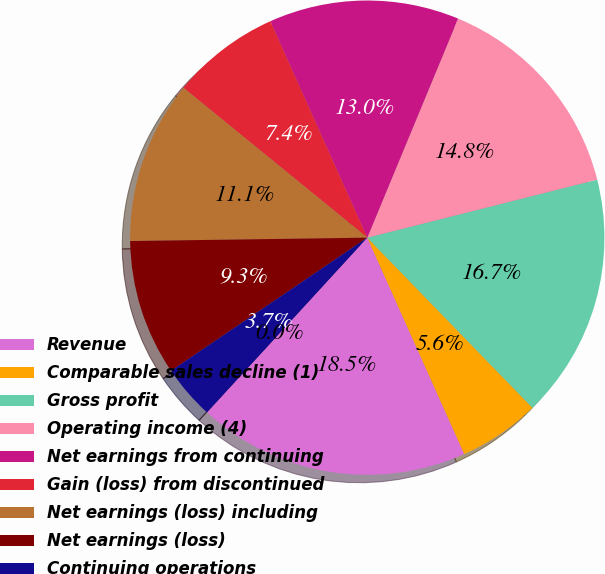<chart> <loc_0><loc_0><loc_500><loc_500><pie_chart><fcel>Revenue<fcel>Comparable sales decline (1)<fcel>Gross profit<fcel>Operating income (4)<fcel>Net earnings from continuing<fcel>Gain (loss) from discontinued<fcel>Net earnings (loss) including<fcel>Net earnings (loss)<fcel>Continuing operations<fcel>Discontinued operations<nl><fcel>18.52%<fcel>5.56%<fcel>16.67%<fcel>14.81%<fcel>12.96%<fcel>7.41%<fcel>11.11%<fcel>9.26%<fcel>3.7%<fcel>0.0%<nl></chart> 